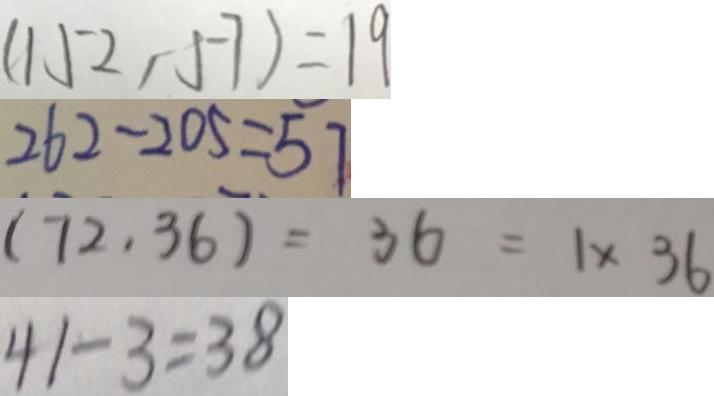Convert formula to latex. <formula><loc_0><loc_0><loc_500><loc_500>( 1 5 2 , 5 7 ) = 1 9 
 2 6 2 - 2 0 5 = 5 7 
 ( 7 2 . 3 6 ) = 3 6 = 1 \times 3 6 
 4 1 - 3 = 3 8</formula> 